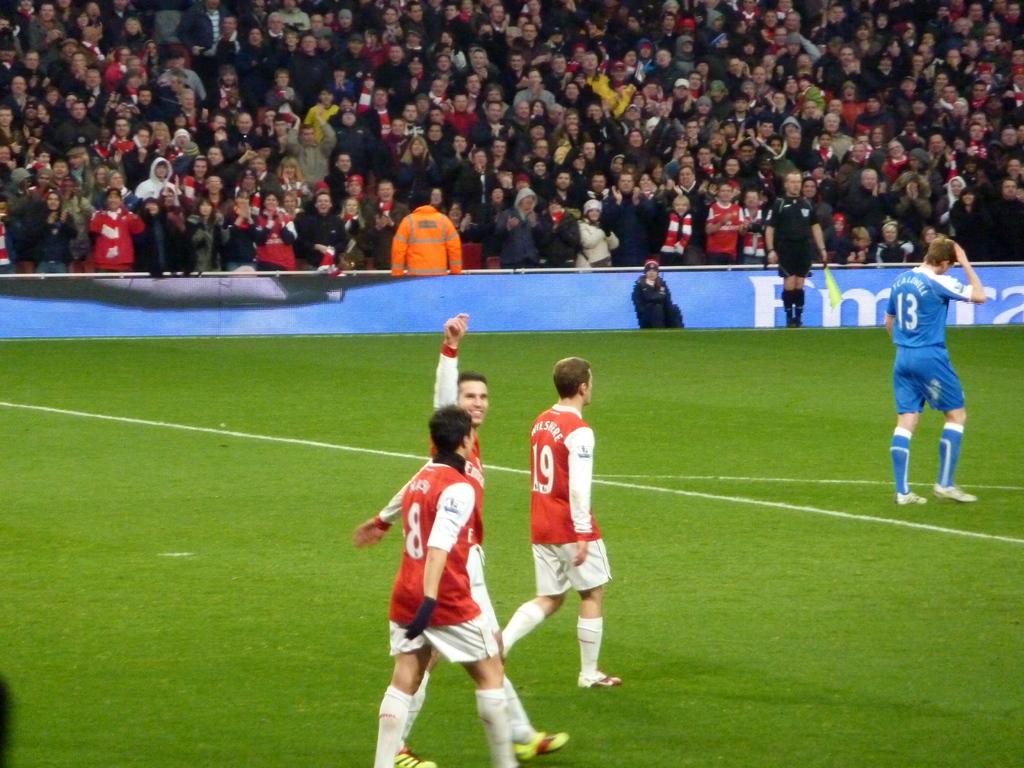What number is on the blue player's shirt?
Your answer should be very brief. 13. What is the number on the left person's red jersey?
Your answer should be very brief. 8. 